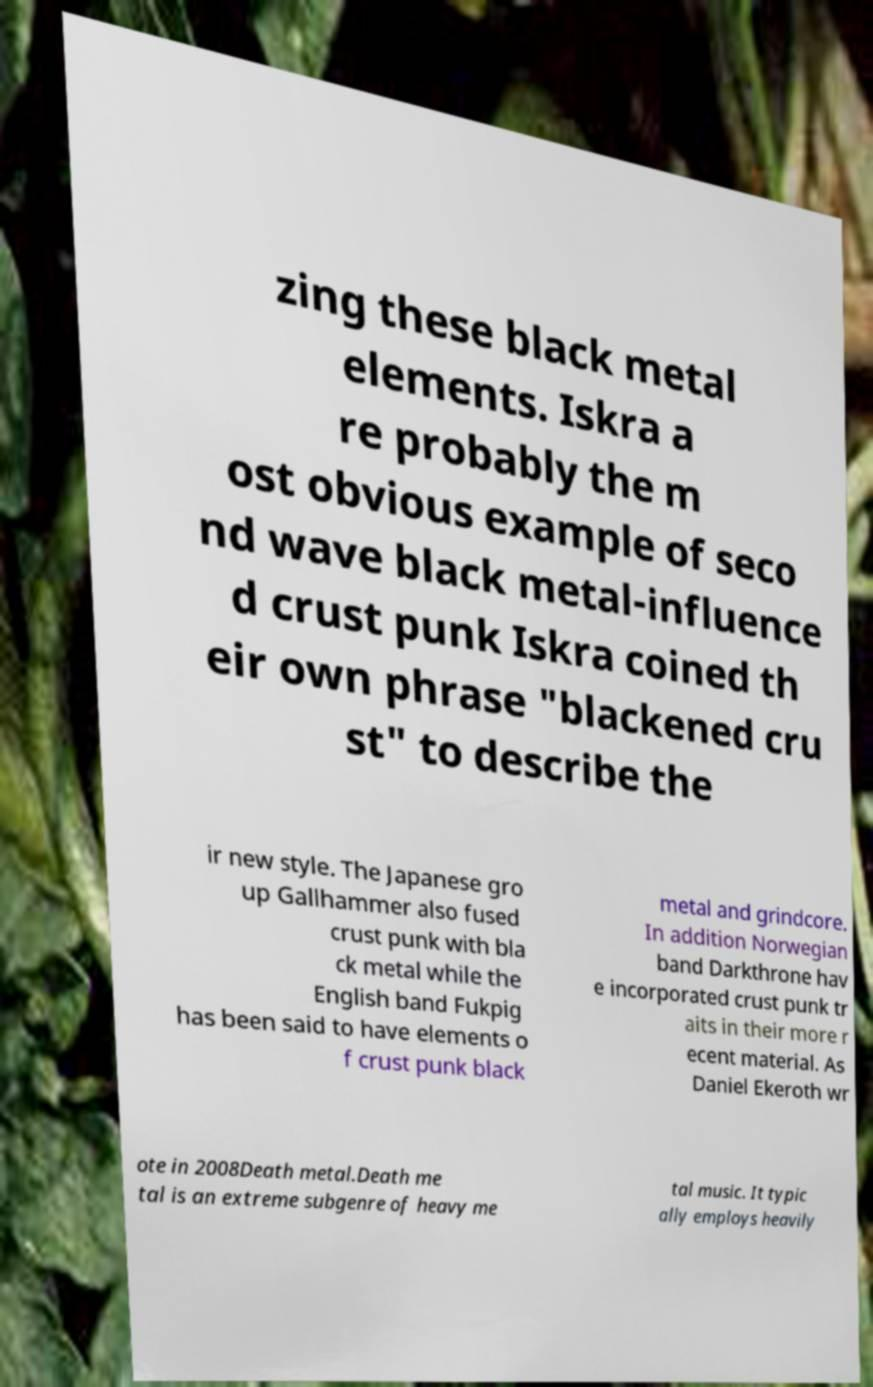Could you extract and type out the text from this image? zing these black metal elements. Iskra a re probably the m ost obvious example of seco nd wave black metal-influence d crust punk Iskra coined th eir own phrase "blackened cru st" to describe the ir new style. The Japanese gro up Gallhammer also fused crust punk with bla ck metal while the English band Fukpig has been said to have elements o f crust punk black metal and grindcore. In addition Norwegian band Darkthrone hav e incorporated crust punk tr aits in their more r ecent material. As Daniel Ekeroth wr ote in 2008Death metal.Death me tal is an extreme subgenre of heavy me tal music. It typic ally employs heavily 